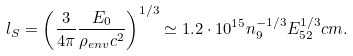<formula> <loc_0><loc_0><loc_500><loc_500>l _ { S } = \left ( \frac { 3 } { 4 \pi } \frac { E _ { 0 } } { \rho _ { e n v } c ^ { 2 } } \right ) ^ { 1 / 3 } \simeq 1 . 2 \cdot 1 0 ^ { 1 5 } n _ { 9 } ^ { - 1 / 3 } E _ { 5 2 } ^ { 1 / 3 } c m .</formula> 